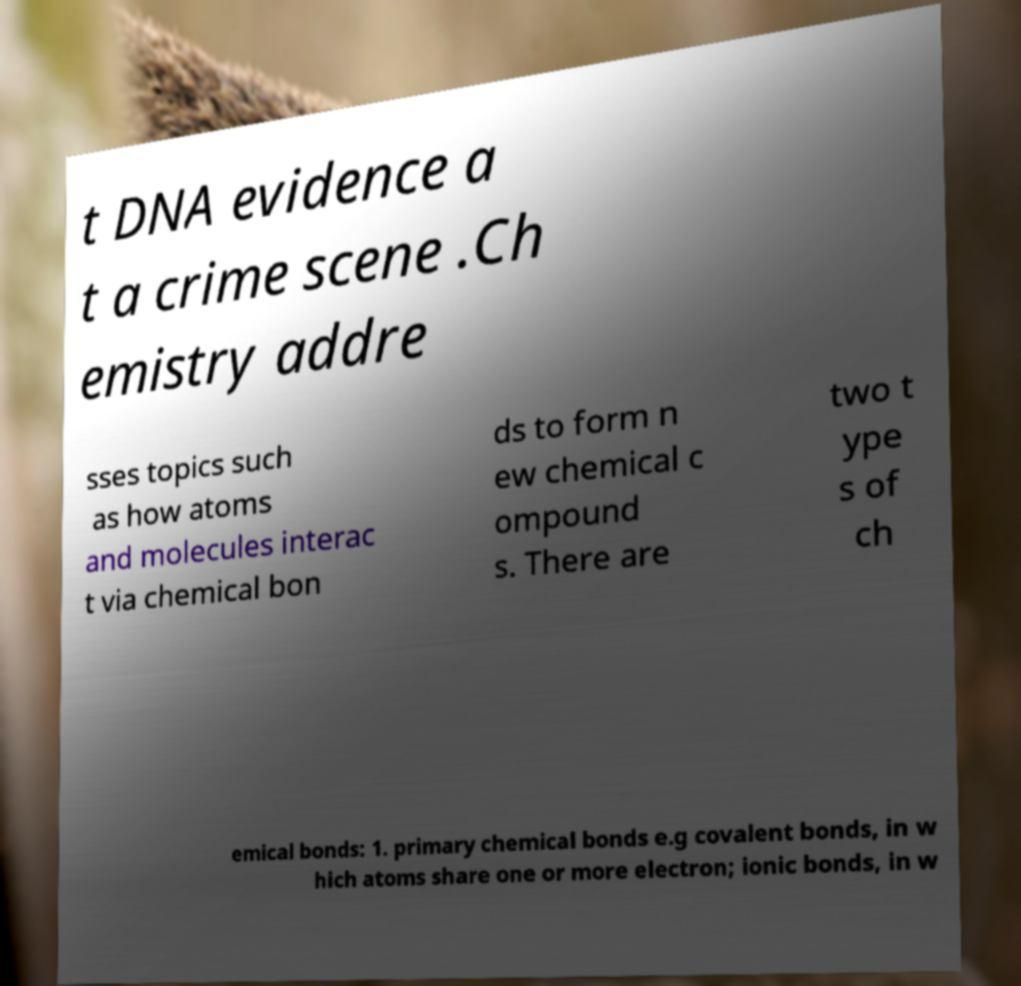Could you extract and type out the text from this image? t DNA evidence a t a crime scene .Ch emistry addre sses topics such as how atoms and molecules interac t via chemical bon ds to form n ew chemical c ompound s. There are two t ype s of ch emical bonds: 1. primary chemical bonds e.g covalent bonds, in w hich atoms share one or more electron; ionic bonds, in w 